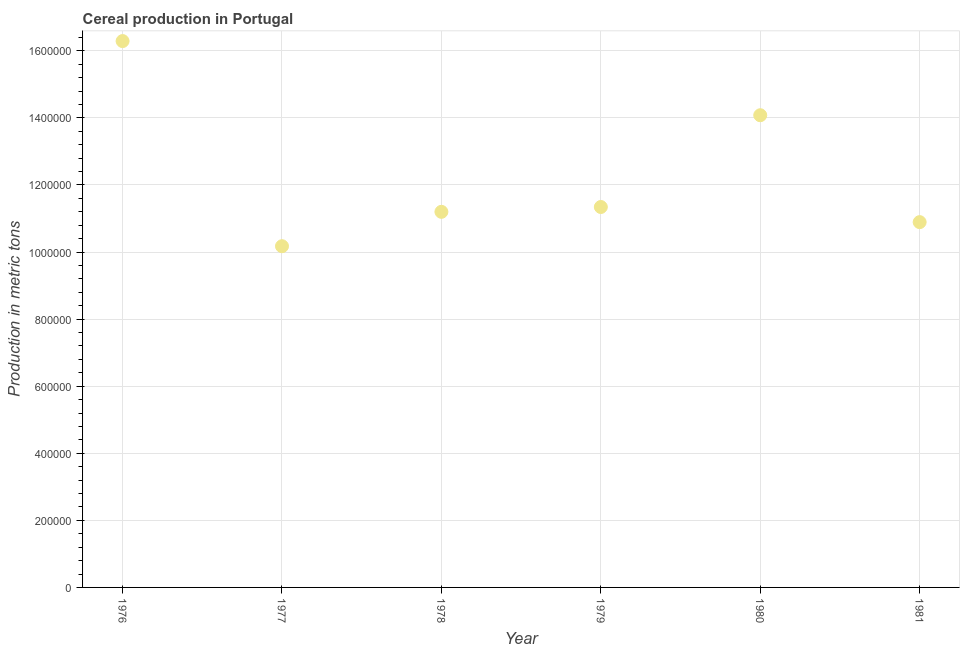What is the cereal production in 1977?
Your answer should be very brief. 1.02e+06. Across all years, what is the maximum cereal production?
Keep it short and to the point. 1.63e+06. Across all years, what is the minimum cereal production?
Offer a terse response. 1.02e+06. In which year was the cereal production maximum?
Give a very brief answer. 1976. In which year was the cereal production minimum?
Offer a very short reply. 1977. What is the sum of the cereal production?
Offer a terse response. 7.40e+06. What is the difference between the cereal production in 1976 and 1980?
Your answer should be compact. 2.21e+05. What is the average cereal production per year?
Give a very brief answer. 1.23e+06. What is the median cereal production?
Offer a very short reply. 1.13e+06. In how many years, is the cereal production greater than 1360000 metric tons?
Your answer should be very brief. 2. What is the ratio of the cereal production in 1976 to that in 1979?
Keep it short and to the point. 1.44. What is the difference between the highest and the second highest cereal production?
Offer a terse response. 2.21e+05. What is the difference between the highest and the lowest cereal production?
Provide a succinct answer. 6.12e+05. In how many years, is the cereal production greater than the average cereal production taken over all years?
Provide a succinct answer. 2. What is the difference between two consecutive major ticks on the Y-axis?
Your answer should be compact. 2.00e+05. Does the graph contain any zero values?
Offer a very short reply. No. What is the title of the graph?
Your answer should be very brief. Cereal production in Portugal. What is the label or title of the X-axis?
Keep it short and to the point. Year. What is the label or title of the Y-axis?
Provide a succinct answer. Production in metric tons. What is the Production in metric tons in 1976?
Give a very brief answer. 1.63e+06. What is the Production in metric tons in 1977?
Your response must be concise. 1.02e+06. What is the Production in metric tons in 1978?
Make the answer very short. 1.12e+06. What is the Production in metric tons in 1979?
Offer a terse response. 1.13e+06. What is the Production in metric tons in 1980?
Give a very brief answer. 1.41e+06. What is the Production in metric tons in 1981?
Provide a short and direct response. 1.09e+06. What is the difference between the Production in metric tons in 1976 and 1977?
Give a very brief answer. 6.12e+05. What is the difference between the Production in metric tons in 1976 and 1978?
Offer a terse response. 5.09e+05. What is the difference between the Production in metric tons in 1976 and 1979?
Ensure brevity in your answer.  4.95e+05. What is the difference between the Production in metric tons in 1976 and 1980?
Make the answer very short. 2.21e+05. What is the difference between the Production in metric tons in 1976 and 1981?
Your answer should be very brief. 5.40e+05. What is the difference between the Production in metric tons in 1977 and 1978?
Provide a short and direct response. -1.02e+05. What is the difference between the Production in metric tons in 1977 and 1979?
Provide a succinct answer. -1.17e+05. What is the difference between the Production in metric tons in 1977 and 1980?
Offer a terse response. -3.90e+05. What is the difference between the Production in metric tons in 1977 and 1981?
Ensure brevity in your answer.  -7.18e+04. What is the difference between the Production in metric tons in 1978 and 1979?
Make the answer very short. -1.44e+04. What is the difference between the Production in metric tons in 1978 and 1980?
Give a very brief answer. -2.88e+05. What is the difference between the Production in metric tons in 1978 and 1981?
Give a very brief answer. 3.07e+04. What is the difference between the Production in metric tons in 1979 and 1980?
Offer a very short reply. -2.74e+05. What is the difference between the Production in metric tons in 1979 and 1981?
Provide a succinct answer. 4.51e+04. What is the difference between the Production in metric tons in 1980 and 1981?
Give a very brief answer. 3.19e+05. What is the ratio of the Production in metric tons in 1976 to that in 1977?
Your answer should be very brief. 1.6. What is the ratio of the Production in metric tons in 1976 to that in 1978?
Offer a very short reply. 1.46. What is the ratio of the Production in metric tons in 1976 to that in 1979?
Your response must be concise. 1.44. What is the ratio of the Production in metric tons in 1976 to that in 1980?
Your answer should be compact. 1.16. What is the ratio of the Production in metric tons in 1976 to that in 1981?
Your response must be concise. 1.5. What is the ratio of the Production in metric tons in 1977 to that in 1978?
Your answer should be compact. 0.91. What is the ratio of the Production in metric tons in 1977 to that in 1979?
Your answer should be compact. 0.9. What is the ratio of the Production in metric tons in 1977 to that in 1980?
Ensure brevity in your answer.  0.72. What is the ratio of the Production in metric tons in 1977 to that in 1981?
Your answer should be very brief. 0.93. What is the ratio of the Production in metric tons in 1978 to that in 1979?
Provide a short and direct response. 0.99. What is the ratio of the Production in metric tons in 1978 to that in 1980?
Offer a terse response. 0.8. What is the ratio of the Production in metric tons in 1978 to that in 1981?
Give a very brief answer. 1.03. What is the ratio of the Production in metric tons in 1979 to that in 1980?
Your response must be concise. 0.81. What is the ratio of the Production in metric tons in 1979 to that in 1981?
Your response must be concise. 1.04. What is the ratio of the Production in metric tons in 1980 to that in 1981?
Offer a very short reply. 1.29. 